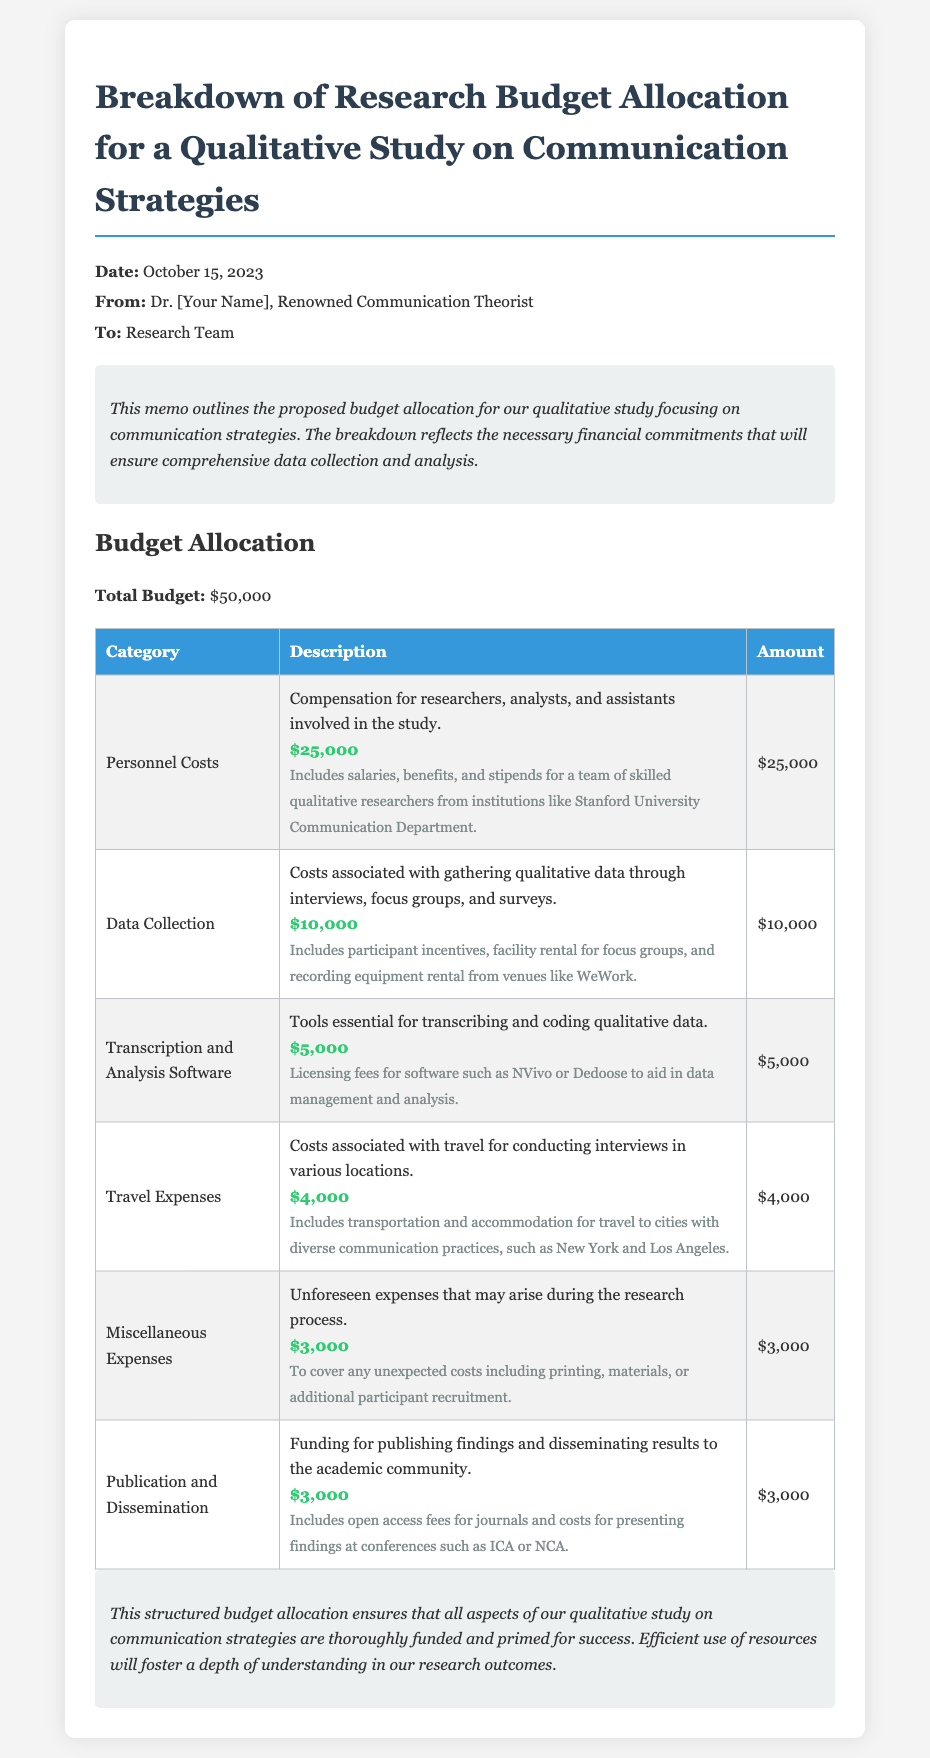What is the total budget? The total budget outlined in the memo is specified as $50,000.
Answer: $50,000 What is allocated for personnel costs? The personnel costs allocation in the budget is detailed as $25,000.
Answer: $25,000 How much is allocated for data collection? The amount allocated for data collection is given as $10,000.
Answer: $10,000 What is the purpose of transcription and analysis software expense? The purpose mentioned for this expense is to aid in data management and analysis through licensing fees for software.
Answer: Transcribing and coding qualitative data What are the travel expenses for? The travel expenses are intended for conducting interviews in various locations.
Answer: Conducting interviews Which cities are highlighted for travel? The memo mentions New York and Los Angeles as targeted cities for research travel.
Answer: New York and Los Angeles What is the amount set aside for miscellaneous expenses? The miscellaneous expenses are budgeted at $3,000 as noted in the allocation table.
Answer: $3,000 What conference fees does the publication and dissemination cost cover? The publication costs mentioned include open access fees for journals and presenting findings at conferences.
Answer: ICA or NCA What is the date of the memo? The memo indicates the date as October 15, 2023.
Answer: October 15, 2023 Who is the recipient of the memo? The memo is addressed to the research team, indicated in the header section.
Answer: Research Team 